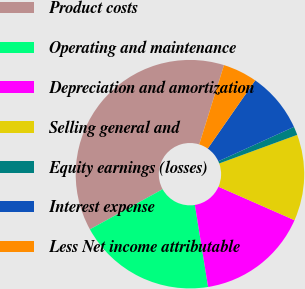<chart> <loc_0><loc_0><loc_500><loc_500><pie_chart><fcel>Product costs<fcel>Operating and maintenance<fcel>Depreciation and amortization<fcel>Selling general and<fcel>Equity earnings (losses)<fcel>Interest expense<fcel>Less Net income attributable<nl><fcel>37.84%<fcel>19.52%<fcel>15.86%<fcel>12.19%<fcel>1.2%<fcel>8.53%<fcel>4.86%<nl></chart> 